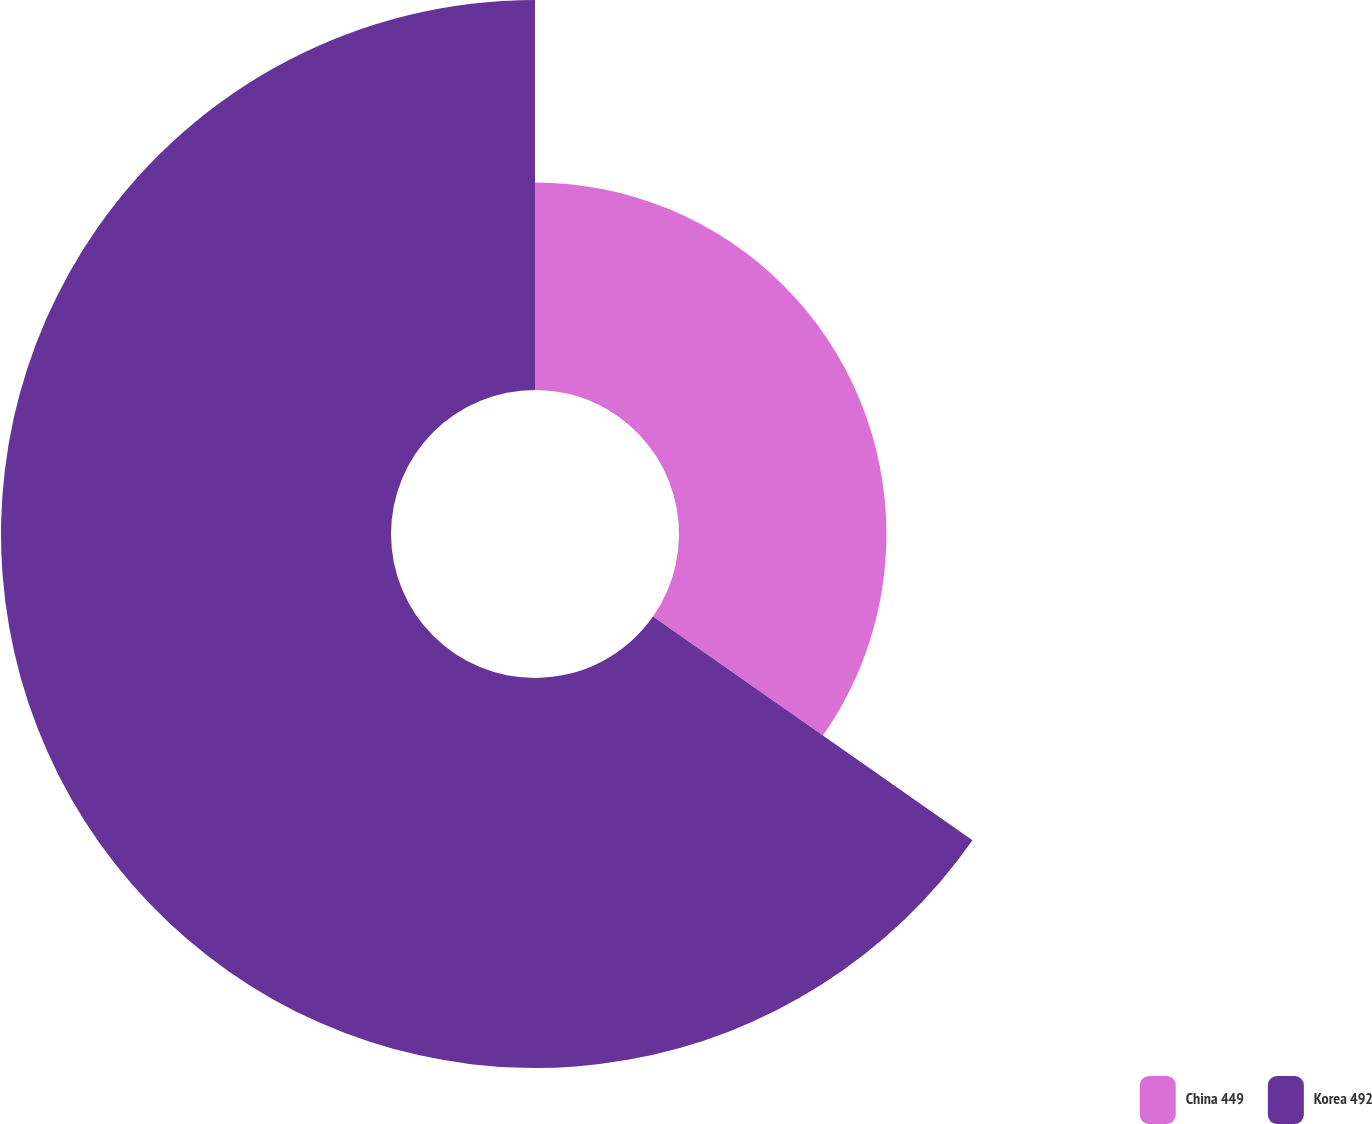Convert chart. <chart><loc_0><loc_0><loc_500><loc_500><pie_chart><fcel>China 449<fcel>Korea 492<nl><fcel>34.72%<fcel>65.28%<nl></chart> 